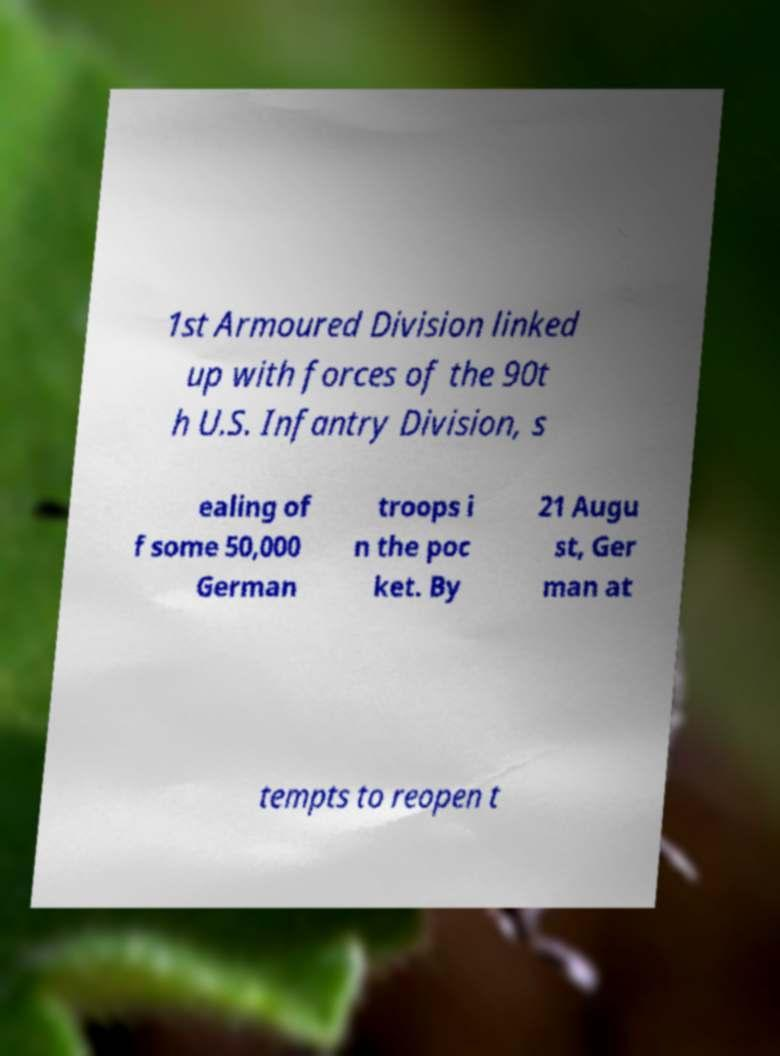I need the written content from this picture converted into text. Can you do that? 1st Armoured Division linked up with forces of the 90t h U.S. Infantry Division, s ealing of f some 50,000 German troops i n the poc ket. By 21 Augu st, Ger man at tempts to reopen t 